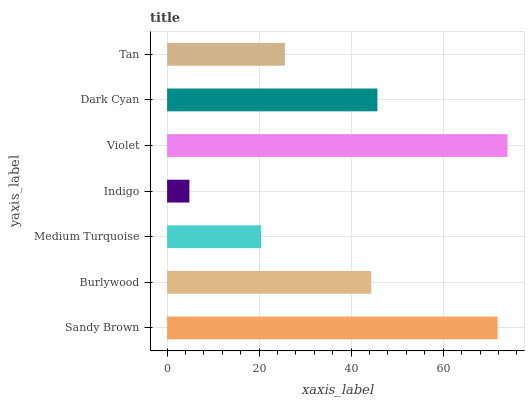Is Indigo the minimum?
Answer yes or no. Yes. Is Violet the maximum?
Answer yes or no. Yes. Is Burlywood the minimum?
Answer yes or no. No. Is Burlywood the maximum?
Answer yes or no. No. Is Sandy Brown greater than Burlywood?
Answer yes or no. Yes. Is Burlywood less than Sandy Brown?
Answer yes or no. Yes. Is Burlywood greater than Sandy Brown?
Answer yes or no. No. Is Sandy Brown less than Burlywood?
Answer yes or no. No. Is Burlywood the high median?
Answer yes or no. Yes. Is Burlywood the low median?
Answer yes or no. Yes. Is Sandy Brown the high median?
Answer yes or no. No. Is Violet the low median?
Answer yes or no. No. 